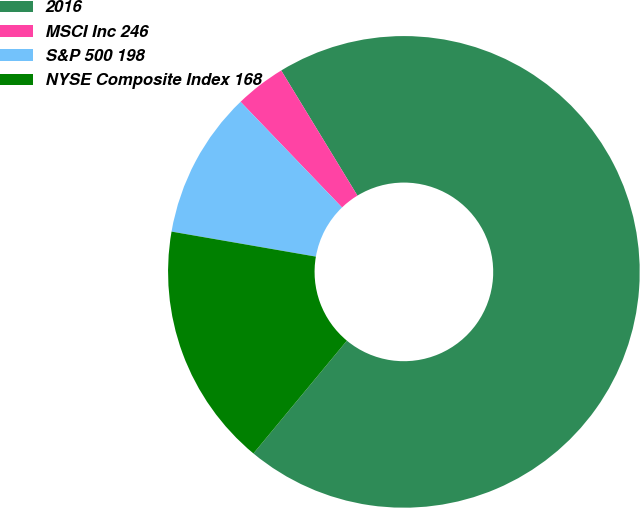<chart> <loc_0><loc_0><loc_500><loc_500><pie_chart><fcel>2016<fcel>MSCI Inc 246<fcel>S&P 500 198<fcel>NYSE Composite Index 168<nl><fcel>69.72%<fcel>3.47%<fcel>10.09%<fcel>16.72%<nl></chart> 